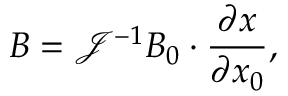<formula> <loc_0><loc_0><loc_500><loc_500>B = \mathcal { J } ^ { - 1 } B _ { 0 } \cdot \frac { \partial x } { \partial x _ { 0 } } ,</formula> 